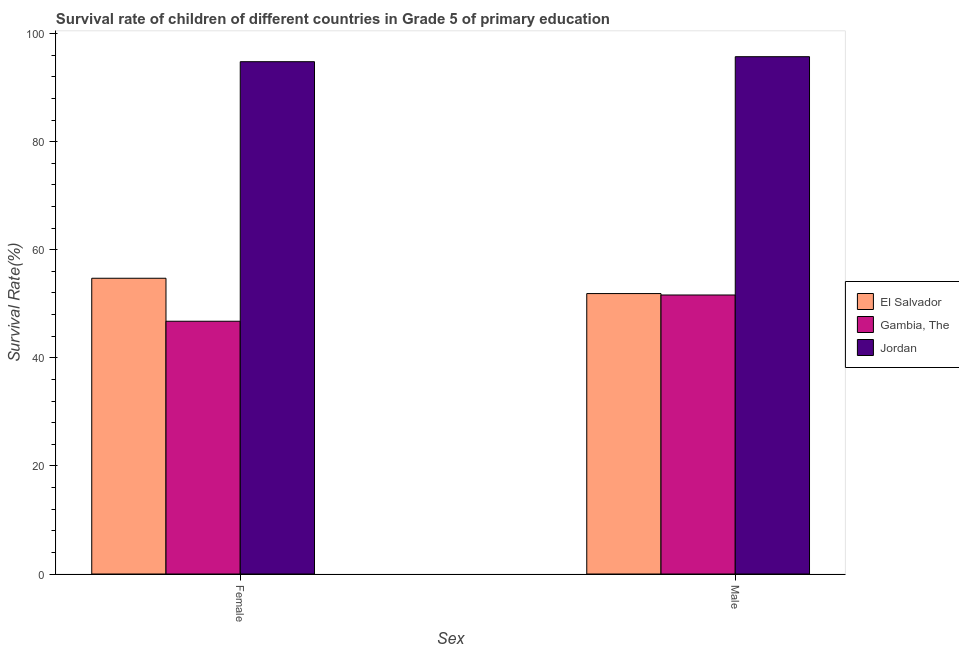How many different coloured bars are there?
Offer a terse response. 3. How many bars are there on the 2nd tick from the left?
Your response must be concise. 3. What is the label of the 2nd group of bars from the left?
Provide a succinct answer. Male. What is the survival rate of female students in primary education in Jordan?
Provide a succinct answer. 94.8. Across all countries, what is the maximum survival rate of male students in primary education?
Give a very brief answer. 95.73. Across all countries, what is the minimum survival rate of female students in primary education?
Give a very brief answer. 46.77. In which country was the survival rate of male students in primary education maximum?
Give a very brief answer. Jordan. In which country was the survival rate of female students in primary education minimum?
Provide a succinct answer. Gambia, The. What is the total survival rate of female students in primary education in the graph?
Give a very brief answer. 196.3. What is the difference between the survival rate of female students in primary education in Gambia, The and that in El Salvador?
Offer a terse response. -7.95. What is the difference between the survival rate of female students in primary education in El Salvador and the survival rate of male students in primary education in Gambia, The?
Provide a short and direct response. 3.1. What is the average survival rate of male students in primary education per country?
Make the answer very short. 66.42. What is the difference between the survival rate of female students in primary education and survival rate of male students in primary education in El Salvador?
Offer a terse response. 2.83. What is the ratio of the survival rate of female students in primary education in El Salvador to that in Jordan?
Provide a short and direct response. 0.58. In how many countries, is the survival rate of female students in primary education greater than the average survival rate of female students in primary education taken over all countries?
Offer a very short reply. 1. What does the 1st bar from the left in Female represents?
Give a very brief answer. El Salvador. What does the 3rd bar from the right in Female represents?
Your answer should be very brief. El Salvador. How many countries are there in the graph?
Keep it short and to the point. 3. What is the difference between two consecutive major ticks on the Y-axis?
Provide a short and direct response. 20. Are the values on the major ticks of Y-axis written in scientific E-notation?
Offer a terse response. No. Does the graph contain any zero values?
Your answer should be compact. No. Where does the legend appear in the graph?
Provide a succinct answer. Center right. What is the title of the graph?
Your answer should be compact. Survival rate of children of different countries in Grade 5 of primary education. What is the label or title of the X-axis?
Your response must be concise. Sex. What is the label or title of the Y-axis?
Provide a short and direct response. Survival Rate(%). What is the Survival Rate(%) of El Salvador in Female?
Make the answer very short. 54.72. What is the Survival Rate(%) of Gambia, The in Female?
Your answer should be very brief. 46.77. What is the Survival Rate(%) of Jordan in Female?
Keep it short and to the point. 94.8. What is the Survival Rate(%) in El Salvador in Male?
Provide a succinct answer. 51.89. What is the Survival Rate(%) of Gambia, The in Male?
Offer a very short reply. 51.63. What is the Survival Rate(%) of Jordan in Male?
Offer a terse response. 95.73. Across all Sex, what is the maximum Survival Rate(%) of El Salvador?
Keep it short and to the point. 54.72. Across all Sex, what is the maximum Survival Rate(%) in Gambia, The?
Give a very brief answer. 51.63. Across all Sex, what is the maximum Survival Rate(%) of Jordan?
Your answer should be very brief. 95.73. Across all Sex, what is the minimum Survival Rate(%) of El Salvador?
Make the answer very short. 51.89. Across all Sex, what is the minimum Survival Rate(%) in Gambia, The?
Your response must be concise. 46.77. Across all Sex, what is the minimum Survival Rate(%) in Jordan?
Provide a succinct answer. 94.8. What is the total Survival Rate(%) of El Salvador in the graph?
Make the answer very short. 106.62. What is the total Survival Rate(%) in Gambia, The in the graph?
Your answer should be very brief. 98.4. What is the total Survival Rate(%) of Jordan in the graph?
Offer a very short reply. 190.53. What is the difference between the Survival Rate(%) in El Salvador in Female and that in Male?
Keep it short and to the point. 2.83. What is the difference between the Survival Rate(%) of Gambia, The in Female and that in Male?
Make the answer very short. -4.86. What is the difference between the Survival Rate(%) in Jordan in Female and that in Male?
Make the answer very short. -0.93. What is the difference between the Survival Rate(%) of El Salvador in Female and the Survival Rate(%) of Gambia, The in Male?
Provide a short and direct response. 3.1. What is the difference between the Survival Rate(%) in El Salvador in Female and the Survival Rate(%) in Jordan in Male?
Offer a terse response. -41. What is the difference between the Survival Rate(%) in Gambia, The in Female and the Survival Rate(%) in Jordan in Male?
Your answer should be very brief. -48.95. What is the average Survival Rate(%) of El Salvador per Sex?
Offer a terse response. 53.31. What is the average Survival Rate(%) in Gambia, The per Sex?
Give a very brief answer. 49.2. What is the average Survival Rate(%) in Jordan per Sex?
Provide a succinct answer. 95.26. What is the difference between the Survival Rate(%) of El Salvador and Survival Rate(%) of Gambia, The in Female?
Your answer should be very brief. 7.95. What is the difference between the Survival Rate(%) of El Salvador and Survival Rate(%) of Jordan in Female?
Keep it short and to the point. -40.07. What is the difference between the Survival Rate(%) of Gambia, The and Survival Rate(%) of Jordan in Female?
Make the answer very short. -48.03. What is the difference between the Survival Rate(%) in El Salvador and Survival Rate(%) in Gambia, The in Male?
Offer a terse response. 0.26. What is the difference between the Survival Rate(%) of El Salvador and Survival Rate(%) of Jordan in Male?
Give a very brief answer. -43.83. What is the difference between the Survival Rate(%) of Gambia, The and Survival Rate(%) of Jordan in Male?
Your response must be concise. -44.1. What is the ratio of the Survival Rate(%) of El Salvador in Female to that in Male?
Offer a very short reply. 1.05. What is the ratio of the Survival Rate(%) in Gambia, The in Female to that in Male?
Keep it short and to the point. 0.91. What is the ratio of the Survival Rate(%) of Jordan in Female to that in Male?
Provide a succinct answer. 0.99. What is the difference between the highest and the second highest Survival Rate(%) in El Salvador?
Make the answer very short. 2.83. What is the difference between the highest and the second highest Survival Rate(%) in Gambia, The?
Ensure brevity in your answer.  4.86. What is the difference between the highest and the second highest Survival Rate(%) of Jordan?
Provide a short and direct response. 0.93. What is the difference between the highest and the lowest Survival Rate(%) of El Salvador?
Give a very brief answer. 2.83. What is the difference between the highest and the lowest Survival Rate(%) in Gambia, The?
Give a very brief answer. 4.86. What is the difference between the highest and the lowest Survival Rate(%) of Jordan?
Keep it short and to the point. 0.93. 